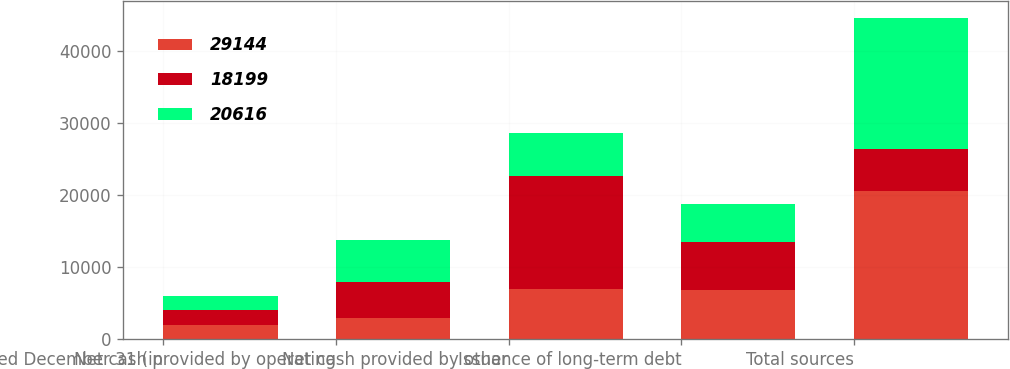Convert chart to OTSL. <chart><loc_0><loc_0><loc_500><loc_500><stacked_bar_chart><ecel><fcel>Years Ended December 31 (in<fcel>Net cash provided by operating<fcel>Net cash provided by other<fcel>Issuance of long-term debt<fcel>Total sources<nl><fcel>29144<fcel>2015<fcel>2877<fcel>7005<fcel>6867<fcel>20616<nl><fcel>18199<fcel>2014<fcel>5007<fcel>15731<fcel>6687<fcel>5860<nl><fcel>20616<fcel>2013<fcel>5865<fcel>5855<fcel>5235<fcel>18199<nl></chart> 